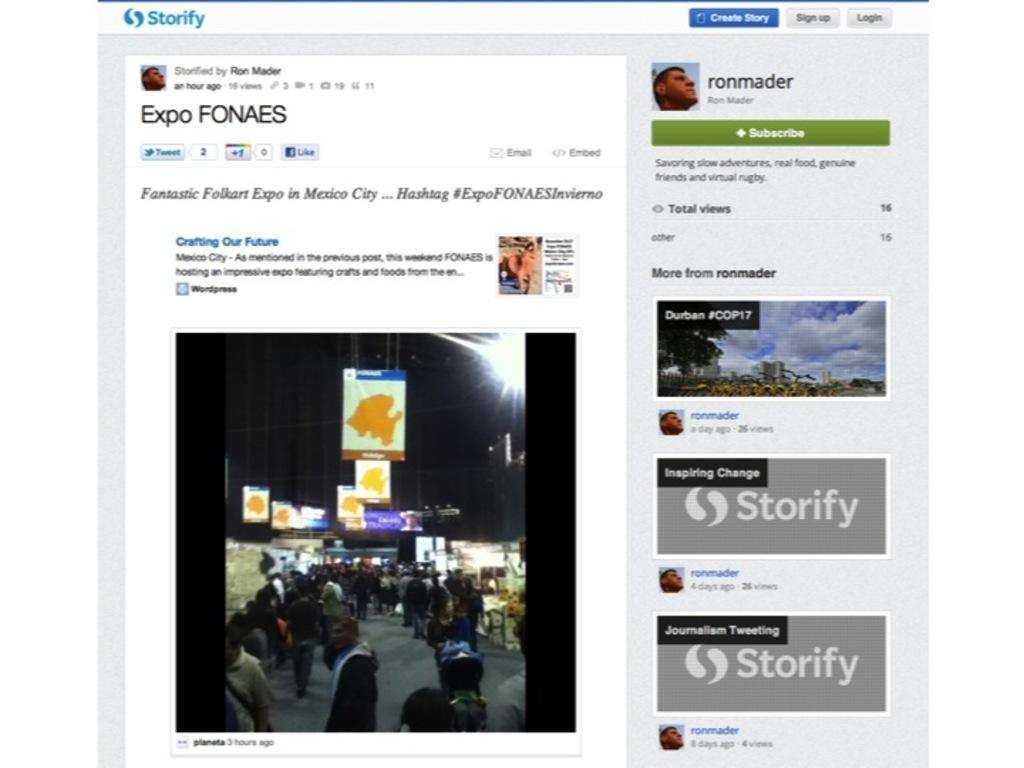What type of content is displayed in the image? The image contains a web page. What visual elements can be found on the web page? The web page has pictures. Are there any interactive elements on the web page? Yes, the web page has links. What type of information can be found on the web page? The web page has text. How many laborers are visible on the web page? There are no laborers present on the web page; it contains pictures, links, and text. 